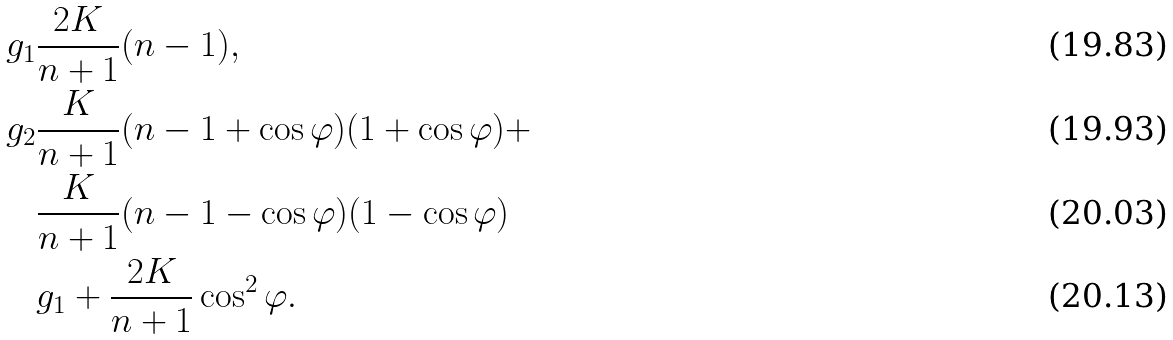Convert formula to latex. <formula><loc_0><loc_0><loc_500><loc_500>g _ { 1 } & \frac { 2 K } { n + 1 } ( n - 1 ) , \\ g _ { 2 } & \frac { K } { n + 1 } ( n - 1 + \cos \varphi ) ( 1 + \cos \varphi ) + \\ & \frac { K } { n + 1 } ( n - 1 - \cos \varphi ) ( 1 - \cos \varphi ) \\ & g _ { 1 } + \frac { 2 K } { n + 1 } \cos ^ { 2 } \varphi .</formula> 